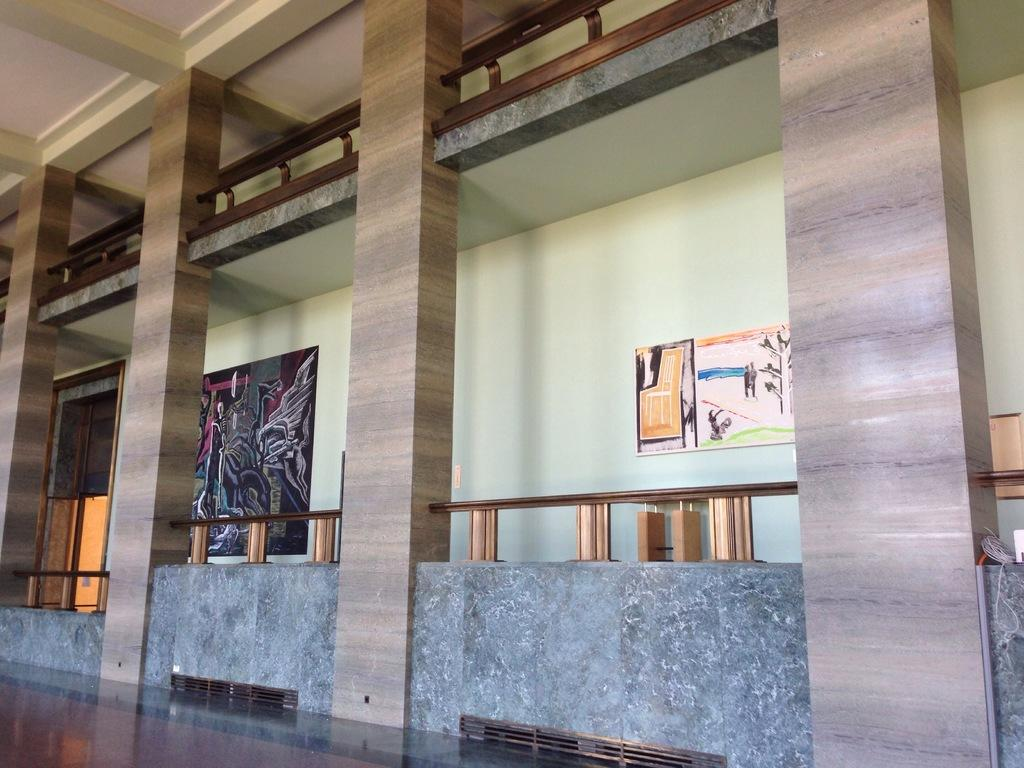What type of location is depicted in the image? The image shows the inside view of a building. What can be seen attached to the wall in the image? There are boards with paintings attached to the wall. Can you describe the entrance in the image? There is a door in the image. What architectural feature is present in the image? There is railing in the image. What part of the building is visible in the image? The ceiling is visible in the image. What structural elements are present in the image? There are pillars in the image. What type of afterthought is depicted in the image? There is no afterthought present in the image; it shows the inside view of a building with various architectural features and objects. Can you tell me how many carriages are visible in the image? There are no carriages present in the image; it depicts the interior of a building with paintings, a door, railing, ceiling, and pillars. 